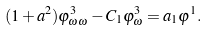<formula> <loc_0><loc_0><loc_500><loc_500>( 1 + a ^ { 2 } ) \varphi ^ { 3 } _ { \omega \omega } - C _ { 1 } \varphi ^ { 3 } _ { \omega } = a _ { 1 } \varphi ^ { 1 } .</formula> 